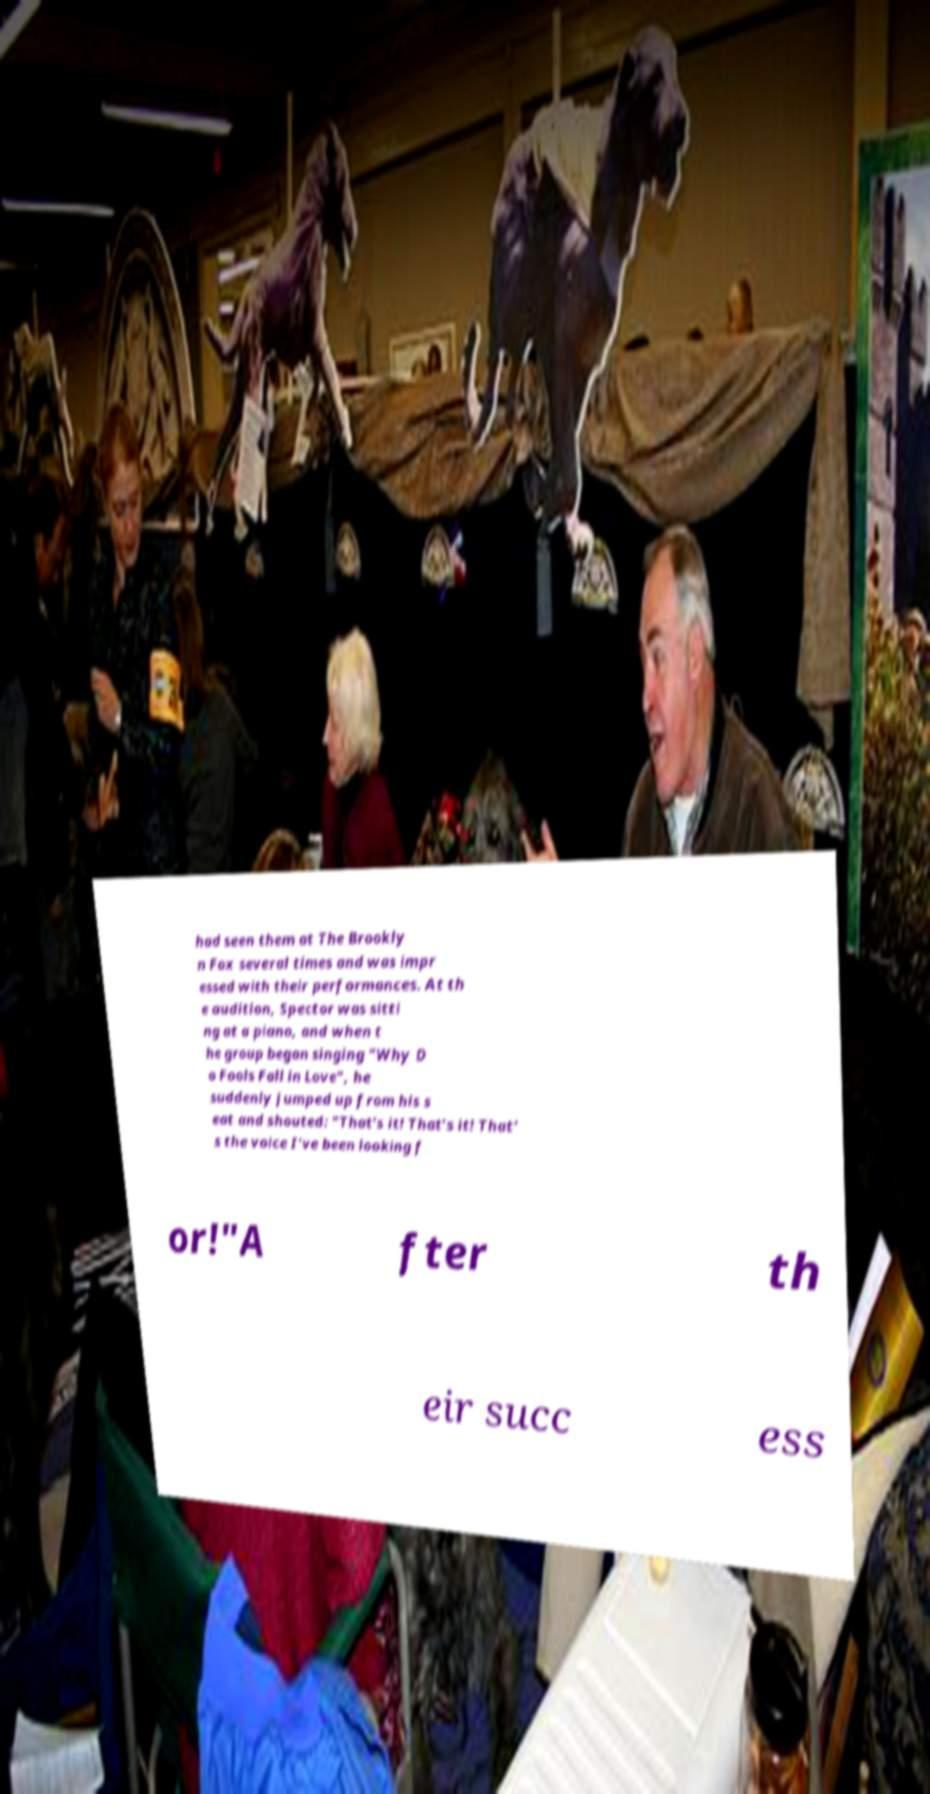Please identify and transcribe the text found in this image. had seen them at The Brookly n Fox several times and was impr essed with their performances. At th e audition, Spector was sitti ng at a piano, and when t he group began singing "Why D o Fools Fall in Love", he suddenly jumped up from his s eat and shouted: "That's it! That's it! That' s the voice I've been looking f or!"A fter th eir succ ess 